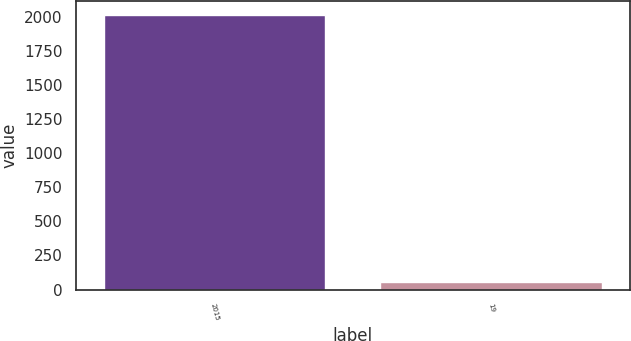<chart> <loc_0><loc_0><loc_500><loc_500><bar_chart><fcel>2015<fcel>19<nl><fcel>2014<fcel>53<nl></chart> 